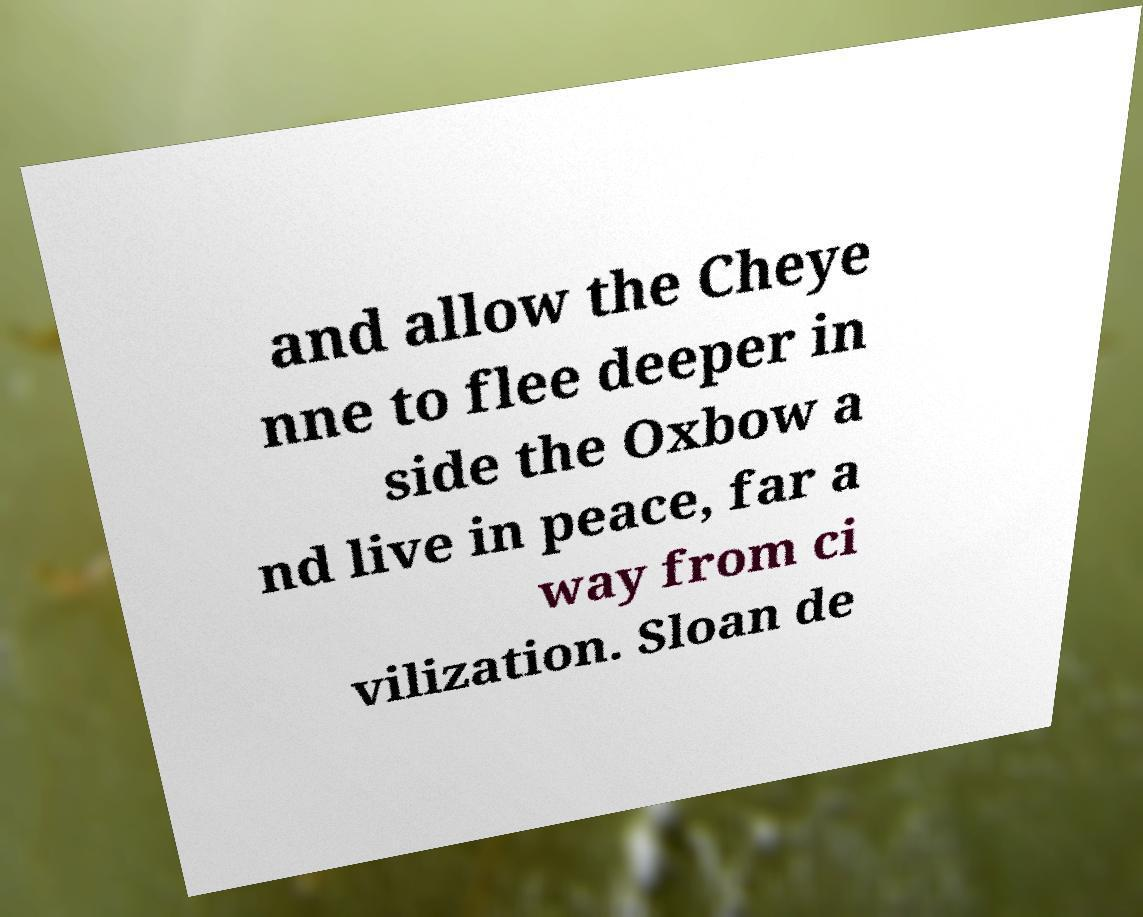Please identify and transcribe the text found in this image. and allow the Cheye nne to flee deeper in side the Oxbow a nd live in peace, far a way from ci vilization. Sloan de 